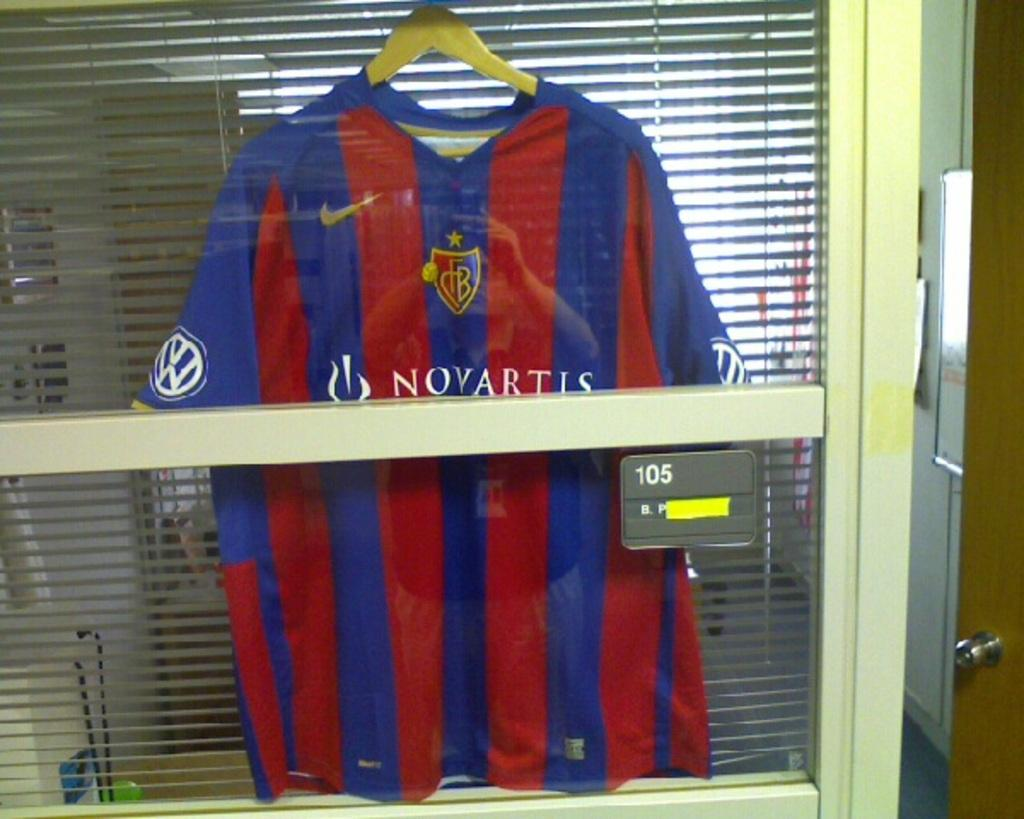Provide a one-sentence caption for the provided image. A blue and red striped shirt with Novartis written on it. 